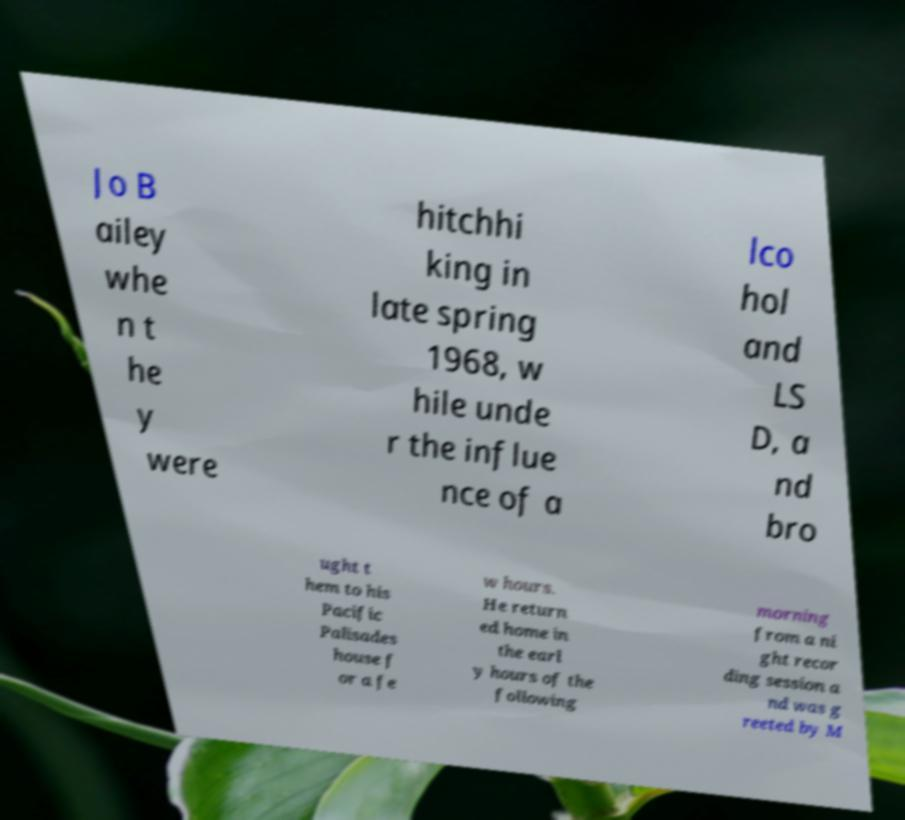Could you assist in decoding the text presented in this image and type it out clearly? Jo B ailey whe n t he y were hitchhi king in late spring 1968, w hile unde r the influe nce of a lco hol and LS D, a nd bro ught t hem to his Pacific Palisades house f or a fe w hours. He return ed home in the earl y hours of the following morning from a ni ght recor ding session a nd was g reeted by M 